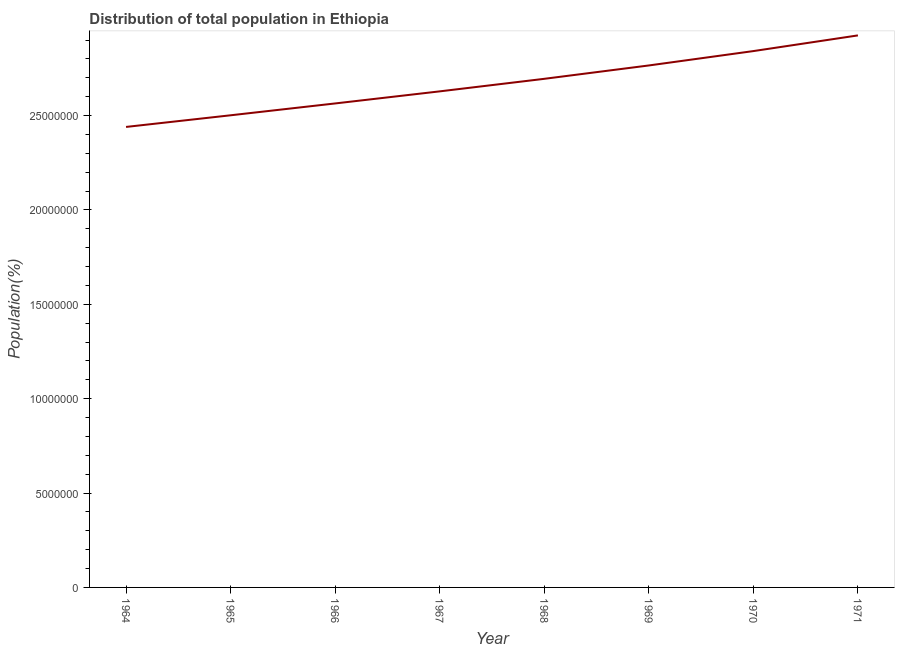What is the population in 1964?
Give a very brief answer. 2.44e+07. Across all years, what is the maximum population?
Your answer should be very brief. 2.92e+07. Across all years, what is the minimum population?
Make the answer very short. 2.44e+07. In which year was the population maximum?
Provide a short and direct response. 1971. In which year was the population minimum?
Make the answer very short. 1964. What is the sum of the population?
Make the answer very short. 2.14e+08. What is the difference between the population in 1966 and 1969?
Ensure brevity in your answer.  -2.01e+06. What is the average population per year?
Ensure brevity in your answer.  2.67e+07. What is the median population?
Your answer should be compact. 2.66e+07. Do a majority of the years between 1968 and 1965 (inclusive) have population greater than 26000000 %?
Offer a terse response. Yes. What is the ratio of the population in 1966 to that in 1969?
Your response must be concise. 0.93. Is the difference between the population in 1966 and 1967 greater than the difference between any two years?
Ensure brevity in your answer.  No. What is the difference between the highest and the second highest population?
Provide a short and direct response. 8.31e+05. What is the difference between the highest and the lowest population?
Provide a short and direct response. 4.85e+06. Does the population monotonically increase over the years?
Offer a terse response. Yes. Are the values on the major ticks of Y-axis written in scientific E-notation?
Your response must be concise. No. Does the graph contain grids?
Your response must be concise. No. What is the title of the graph?
Make the answer very short. Distribution of total population in Ethiopia . What is the label or title of the X-axis?
Make the answer very short. Year. What is the label or title of the Y-axis?
Your answer should be compact. Population(%). What is the Population(%) in 1964?
Offer a very short reply. 2.44e+07. What is the Population(%) of 1965?
Offer a very short reply. 2.50e+07. What is the Population(%) in 1966?
Keep it short and to the point. 2.56e+07. What is the Population(%) of 1967?
Ensure brevity in your answer.  2.63e+07. What is the Population(%) in 1968?
Your response must be concise. 2.69e+07. What is the Population(%) of 1969?
Ensure brevity in your answer.  2.77e+07. What is the Population(%) of 1970?
Give a very brief answer. 2.84e+07. What is the Population(%) of 1971?
Your response must be concise. 2.92e+07. What is the difference between the Population(%) in 1964 and 1965?
Offer a terse response. -6.17e+05. What is the difference between the Population(%) in 1964 and 1966?
Make the answer very short. -1.24e+06. What is the difference between the Population(%) in 1964 and 1967?
Offer a terse response. -1.88e+06. What is the difference between the Population(%) in 1964 and 1968?
Your response must be concise. -2.55e+06. What is the difference between the Population(%) in 1964 and 1969?
Your answer should be very brief. -3.26e+06. What is the difference between the Population(%) in 1964 and 1970?
Your response must be concise. -4.02e+06. What is the difference between the Population(%) in 1964 and 1971?
Keep it short and to the point. -4.85e+06. What is the difference between the Population(%) in 1965 and 1966?
Provide a succinct answer. -6.28e+05. What is the difference between the Population(%) in 1965 and 1967?
Your answer should be compact. -1.27e+06. What is the difference between the Population(%) in 1965 and 1968?
Your answer should be very brief. -1.93e+06. What is the difference between the Population(%) in 1965 and 1969?
Provide a short and direct response. -2.64e+06. What is the difference between the Population(%) in 1965 and 1970?
Ensure brevity in your answer.  -3.40e+06. What is the difference between the Population(%) in 1965 and 1971?
Make the answer very short. -4.23e+06. What is the difference between the Population(%) in 1966 and 1967?
Offer a very short reply. -6.40e+05. What is the difference between the Population(%) in 1966 and 1968?
Provide a short and direct response. -1.30e+06. What is the difference between the Population(%) in 1966 and 1969?
Ensure brevity in your answer.  -2.01e+06. What is the difference between the Population(%) in 1966 and 1970?
Provide a succinct answer. -2.77e+06. What is the difference between the Population(%) in 1966 and 1971?
Keep it short and to the point. -3.60e+06. What is the difference between the Population(%) in 1967 and 1968?
Offer a very short reply. -6.65e+05. What is the difference between the Population(%) in 1967 and 1969?
Your response must be concise. -1.37e+06. What is the difference between the Population(%) in 1967 and 1970?
Your answer should be compact. -2.13e+06. What is the difference between the Population(%) in 1967 and 1971?
Ensure brevity in your answer.  -2.97e+06. What is the difference between the Population(%) in 1968 and 1969?
Ensure brevity in your answer.  -7.08e+05. What is the difference between the Population(%) in 1968 and 1970?
Provide a short and direct response. -1.47e+06. What is the difference between the Population(%) in 1968 and 1971?
Ensure brevity in your answer.  -2.30e+06. What is the difference between the Population(%) in 1969 and 1970?
Provide a short and direct response. -7.61e+05. What is the difference between the Population(%) in 1969 and 1971?
Your answer should be compact. -1.59e+06. What is the difference between the Population(%) in 1970 and 1971?
Provide a succinct answer. -8.31e+05. What is the ratio of the Population(%) in 1964 to that in 1965?
Offer a very short reply. 0.97. What is the ratio of the Population(%) in 1964 to that in 1966?
Give a very brief answer. 0.95. What is the ratio of the Population(%) in 1964 to that in 1967?
Offer a terse response. 0.93. What is the ratio of the Population(%) in 1964 to that in 1968?
Your answer should be compact. 0.91. What is the ratio of the Population(%) in 1964 to that in 1969?
Make the answer very short. 0.88. What is the ratio of the Population(%) in 1964 to that in 1970?
Your response must be concise. 0.86. What is the ratio of the Population(%) in 1964 to that in 1971?
Provide a succinct answer. 0.83. What is the ratio of the Population(%) in 1965 to that in 1968?
Your response must be concise. 0.93. What is the ratio of the Population(%) in 1965 to that in 1969?
Give a very brief answer. 0.91. What is the ratio of the Population(%) in 1965 to that in 1971?
Keep it short and to the point. 0.85. What is the ratio of the Population(%) in 1966 to that in 1968?
Ensure brevity in your answer.  0.95. What is the ratio of the Population(%) in 1966 to that in 1969?
Provide a succinct answer. 0.93. What is the ratio of the Population(%) in 1966 to that in 1970?
Provide a short and direct response. 0.9. What is the ratio of the Population(%) in 1966 to that in 1971?
Your answer should be very brief. 0.88. What is the ratio of the Population(%) in 1967 to that in 1970?
Your answer should be compact. 0.93. What is the ratio of the Population(%) in 1967 to that in 1971?
Provide a succinct answer. 0.9. What is the ratio of the Population(%) in 1968 to that in 1969?
Your answer should be compact. 0.97. What is the ratio of the Population(%) in 1968 to that in 1970?
Offer a terse response. 0.95. What is the ratio of the Population(%) in 1968 to that in 1971?
Your answer should be very brief. 0.92. What is the ratio of the Population(%) in 1969 to that in 1971?
Offer a terse response. 0.95. What is the ratio of the Population(%) in 1970 to that in 1971?
Ensure brevity in your answer.  0.97. 